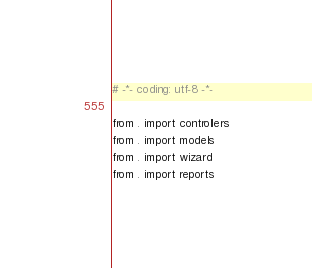Convert code to text. <code><loc_0><loc_0><loc_500><loc_500><_Python_># -*- coding: utf-8 -*-

from . import controllers
from . import models
from . import wizard
from . import reports
</code> 